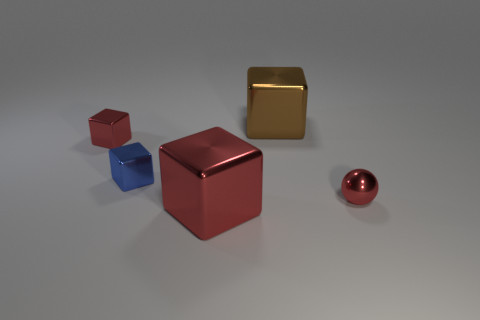Subtract all cyan cubes. Subtract all brown spheres. How many cubes are left? 4 Add 3 small metal blocks. How many objects exist? 8 Subtract all balls. How many objects are left? 4 Add 4 green balls. How many green balls exist? 4 Subtract 0 purple spheres. How many objects are left? 5 Subtract all tiny red metallic spheres. Subtract all brown shiny things. How many objects are left? 3 Add 2 brown shiny cubes. How many brown shiny cubes are left? 3 